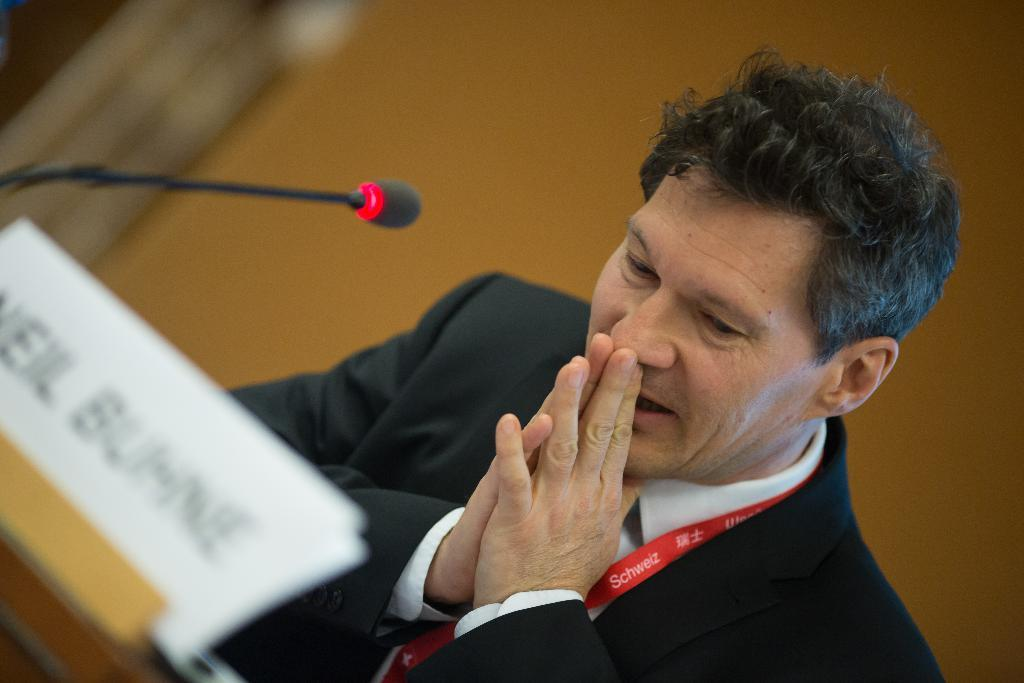What is the person in the image wearing? The person in the image is wearing a black suit. What is the person doing in the image? The person is sitting on a chair. Where is the chair located in relation to the table? The chair is in front of the table. What objects are on the table in the image? There is a name board and a microphone on the table. What color is the wall in the background of the image? The wall in the background of the image is yellow. How many boats are visible in the image? There are no boats present in the image. What type of toy is the person holding in the image? There is no toy visible in the image; the person is sitting on a chair and wearing a black suit. 